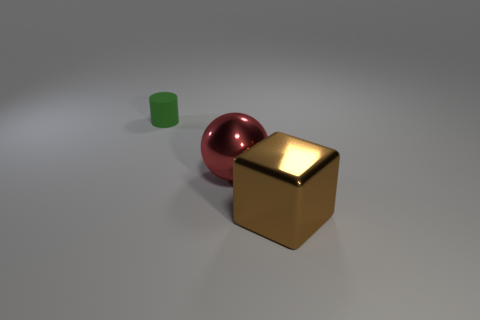Is there anything else that is the same material as the green cylinder?
Offer a very short reply. No. What shape is the thing that is behind the large thing behind the brown shiny object?
Provide a short and direct response. Cylinder. There is another metal object that is the same size as the brown object; what is its color?
Your answer should be compact. Red. Is the number of big brown metallic blocks in front of the brown object less than the number of large brown metallic cubes right of the ball?
Offer a very short reply. Yes. What is the shape of the thing that is in front of the big shiny thing on the left side of the thing in front of the big red shiny ball?
Your answer should be very brief. Cube. How many matte objects are either red balls or small green objects?
Your response must be concise. 1. There is a shiny object that is behind the large metallic object that is right of the big thing that is to the left of the big metal block; what is its color?
Provide a short and direct response. Red. How many other things are there of the same material as the green cylinder?
Provide a short and direct response. 0. How big is the red thing?
Your answer should be very brief. Large. How many things are large red metal spheres or shiny objects that are behind the large brown metal object?
Give a very brief answer. 1. 